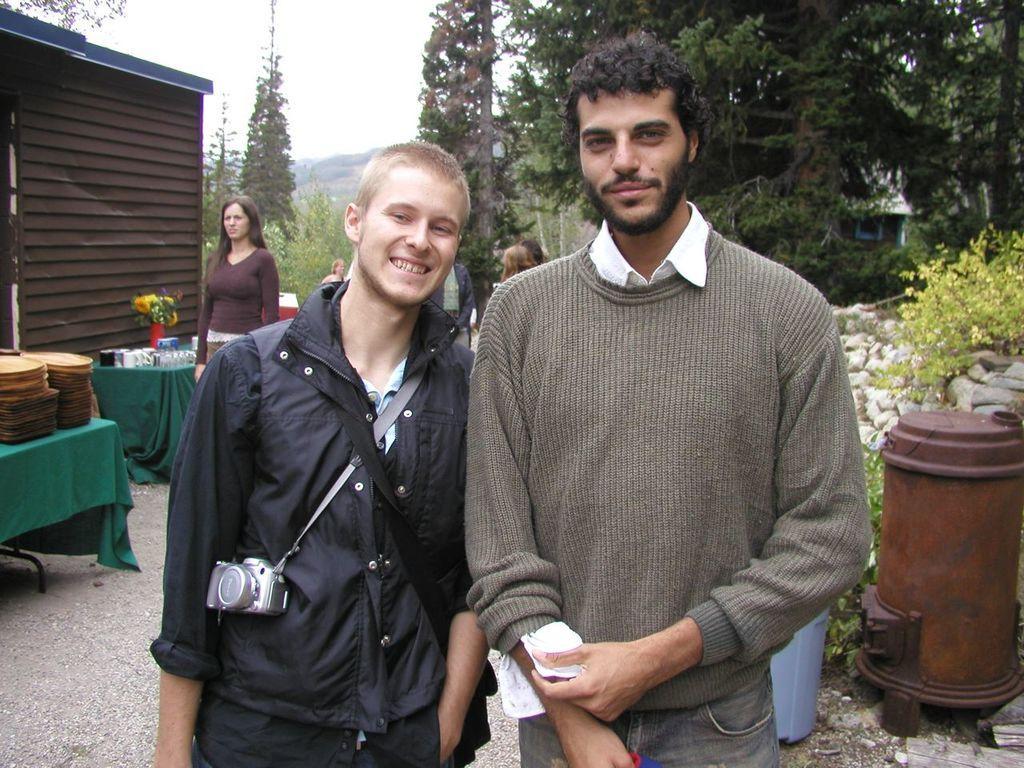Can you describe this image briefly? In a given image I can see a people, trees, stones, tables, flower pot, cloth and some other objects. 